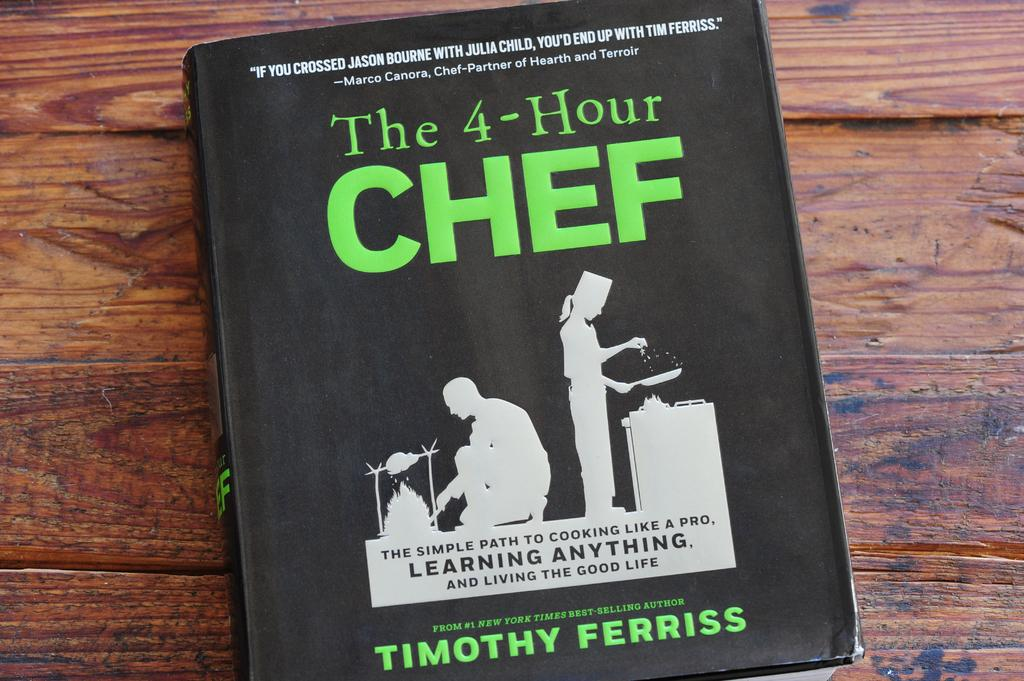Provide a one-sentence caption for the provided image. A copy of the book the four hour chef by timothy ferriss. 